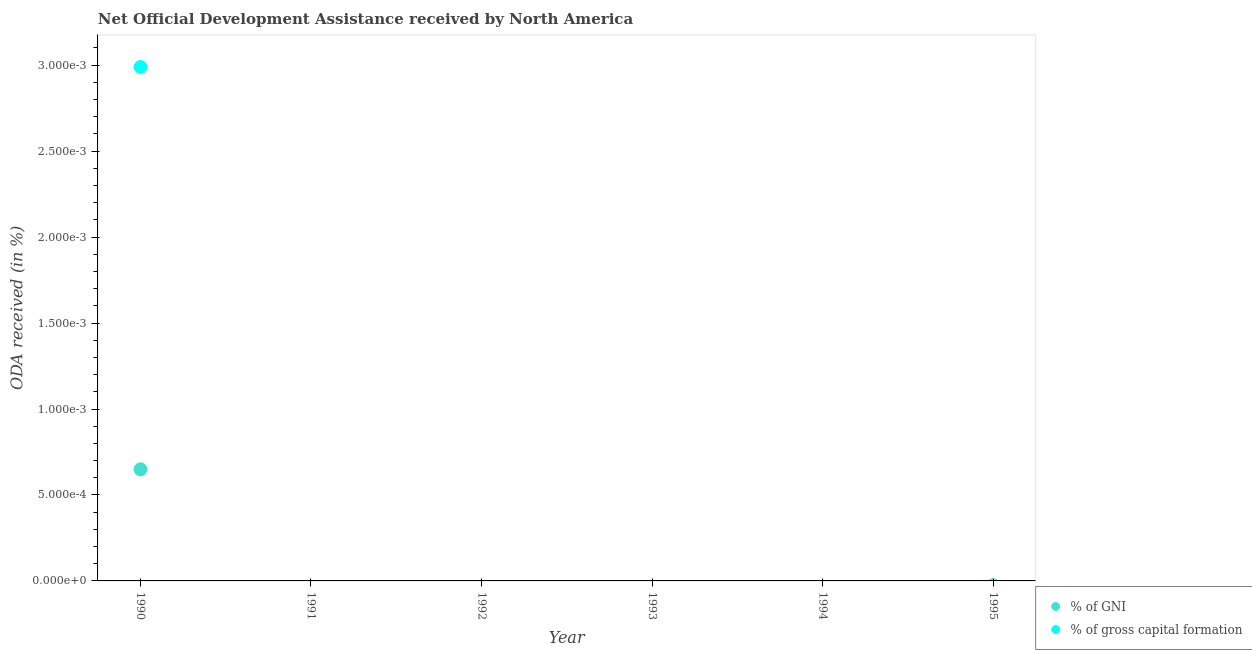What is the oda received as percentage of gross capital formation in 1990?
Provide a short and direct response. 0. Across all years, what is the maximum oda received as percentage of gni?
Offer a terse response. 0. In which year was the oda received as percentage of gross capital formation maximum?
Keep it short and to the point. 1990. What is the total oda received as percentage of gross capital formation in the graph?
Ensure brevity in your answer.  0. What is the average oda received as percentage of gni per year?
Give a very brief answer. 0. In the year 1990, what is the difference between the oda received as percentage of gross capital formation and oda received as percentage of gni?
Ensure brevity in your answer.  0. In how many years, is the oda received as percentage of gross capital formation greater than 0.0022 %?
Keep it short and to the point. 1. What is the difference between the highest and the lowest oda received as percentage of gni?
Your answer should be compact. 0. Does the oda received as percentage of gni monotonically increase over the years?
Give a very brief answer. No. Is the oda received as percentage of gni strictly less than the oda received as percentage of gross capital formation over the years?
Offer a very short reply. No. Are the values on the major ticks of Y-axis written in scientific E-notation?
Make the answer very short. No. Does the graph contain any zero values?
Your response must be concise. Yes. Where does the legend appear in the graph?
Give a very brief answer. Bottom right. How many legend labels are there?
Make the answer very short. 2. What is the title of the graph?
Ensure brevity in your answer.  Net Official Development Assistance received by North America. What is the label or title of the Y-axis?
Make the answer very short. ODA received (in %). What is the ODA received (in %) of % of GNI in 1990?
Provide a succinct answer. 0. What is the ODA received (in %) of % of gross capital formation in 1990?
Provide a succinct answer. 0. What is the ODA received (in %) in % of GNI in 1991?
Provide a short and direct response. 0. What is the ODA received (in %) in % of gross capital formation in 1991?
Ensure brevity in your answer.  0. What is the ODA received (in %) of % of GNI in 1992?
Ensure brevity in your answer.  0. What is the ODA received (in %) of % of gross capital formation in 1992?
Provide a succinct answer. 0. What is the ODA received (in %) of % of gross capital formation in 1993?
Your answer should be very brief. 0. What is the ODA received (in %) of % of gross capital formation in 1994?
Provide a succinct answer. 0. Across all years, what is the maximum ODA received (in %) in % of GNI?
Give a very brief answer. 0. Across all years, what is the maximum ODA received (in %) in % of gross capital formation?
Your response must be concise. 0. What is the total ODA received (in %) of % of GNI in the graph?
Offer a terse response. 0. What is the total ODA received (in %) in % of gross capital formation in the graph?
Provide a succinct answer. 0. What is the average ODA received (in %) in % of GNI per year?
Keep it short and to the point. 0. In the year 1990, what is the difference between the ODA received (in %) of % of GNI and ODA received (in %) of % of gross capital formation?
Make the answer very short. -0. What is the difference between the highest and the lowest ODA received (in %) in % of GNI?
Your answer should be compact. 0. What is the difference between the highest and the lowest ODA received (in %) of % of gross capital formation?
Your answer should be compact. 0. 